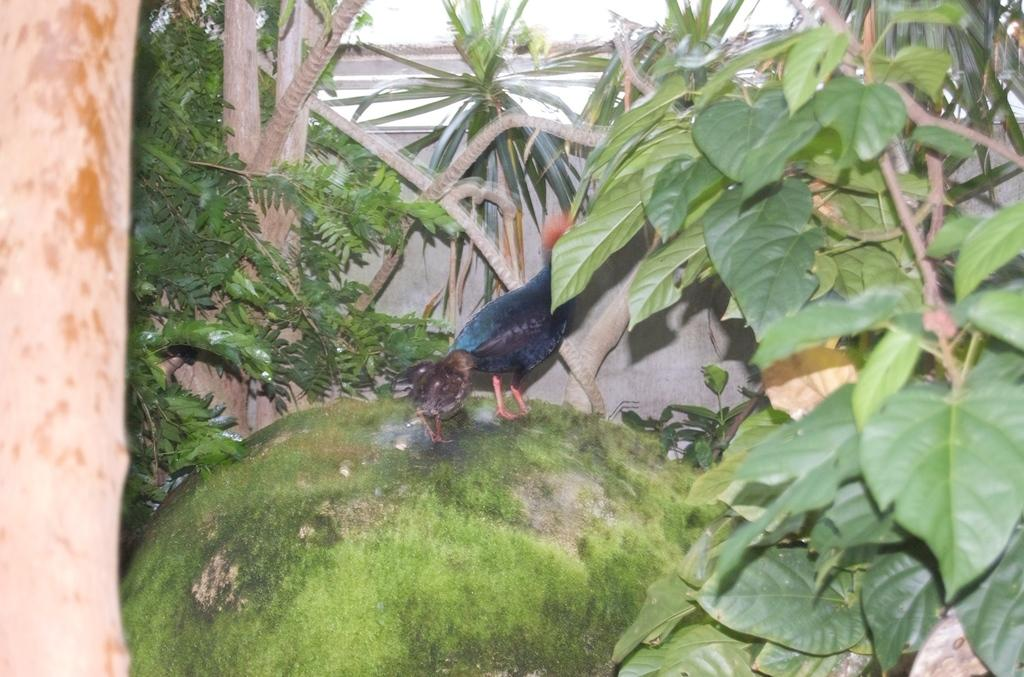What type of animals can be seen on a stone in the image? There are birds visible on a stone in the image. What type of vegetation is present in the image? There are plants in the image. What part of the plants can be seen in the image? Leaves and stems are visible in the image. What type of thread is being used by the plant in the image? There is no thread present in the image; it features birds on a stone and plants with leaves and stems. 